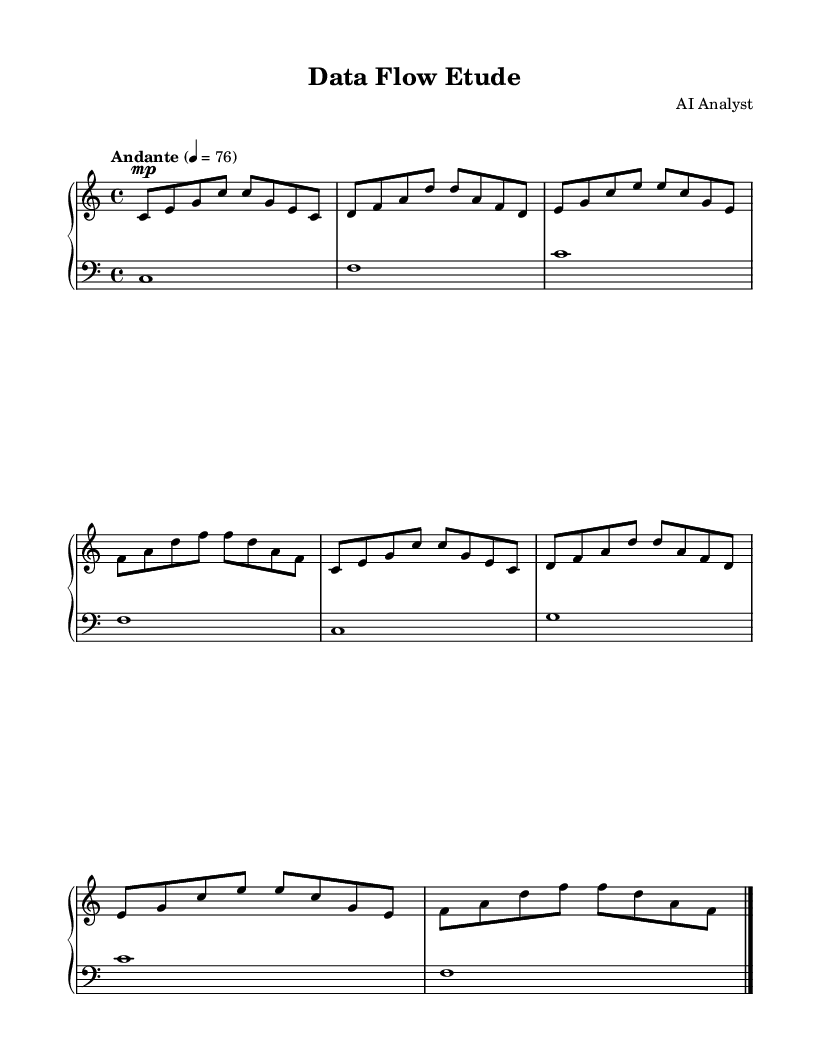What is the key signature of this music? The key signature is indicated by the notes in the staff. Since there are no sharps or flats present, this confirms the key of C major.
Answer: C major What is the time signature of this piece? The time signature is shown at the beginning of the staff as 4/4, indicating that there are four beats in a measure and the quarter note gets one beat.
Answer: 4/4 What is the tempo marking of this composition? The tempo marking, found at the beginning of the score, states "Andante" with a metronome marking of 76, indicating a moderate pace.
Answer: Andante 76 How many measures are in the right hand part? By counting each distinct group of notes separated by vertical lines, there are a total of 8 measures in the right hand part.
Answer: 8 What is the dynamic marking for the right hand? The dynamic marking is shown as "mp," which indicates a medium soft volume for the right-hand part throughout the piece.
Answer: mp Which section of the composition contains a crescendo? A crescendo is indicated in the right-hand music, where the notation becomes progressively louder, indicated by the symbol of increasing volume between two notes.
Answer: Right hand What type of composition is this piece categorized as? By analyzing its structure, simplicity, and repetitive patterns, this piece can be categorized as a minimalist composition, often used to aid focus and concentration.
Answer: Minimalist 